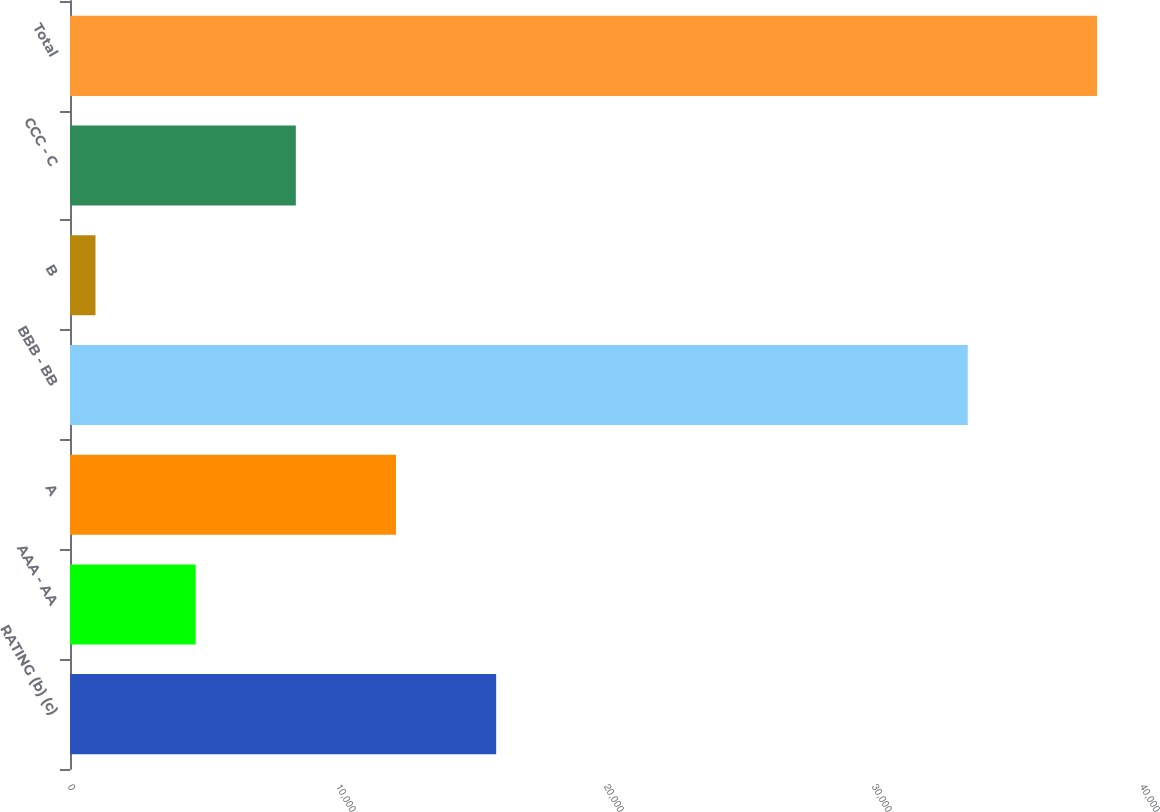Convert chart to OTSL. <chart><loc_0><loc_0><loc_500><loc_500><bar_chart><fcel>RATING (b) (c)<fcel>AAA - AA<fcel>A<fcel>BBB - BB<fcel>B<fcel>CCC - C<fcel>Total<nl><fcel>15901.6<fcel>4689.4<fcel>12164.2<fcel>33497<fcel>952<fcel>8426.8<fcel>38326<nl></chart> 